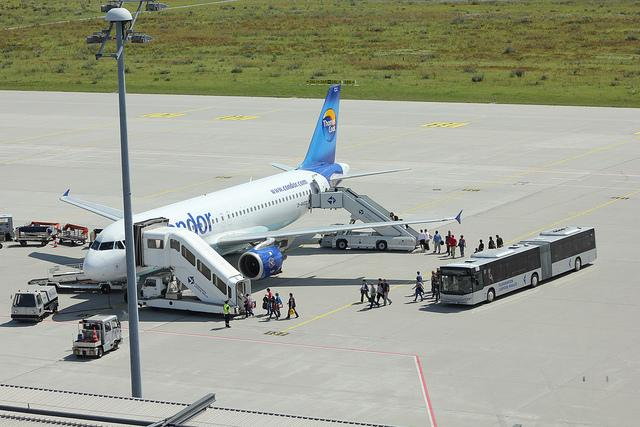What is the name of the blue piece on the end of the plane? Please explain your reasoning. vertical stabilizer. The name is a stabilizer. 